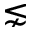Convert formula to latex. <formula><loc_0><loc_0><loc_500><loc_500>\lnsim</formula> 